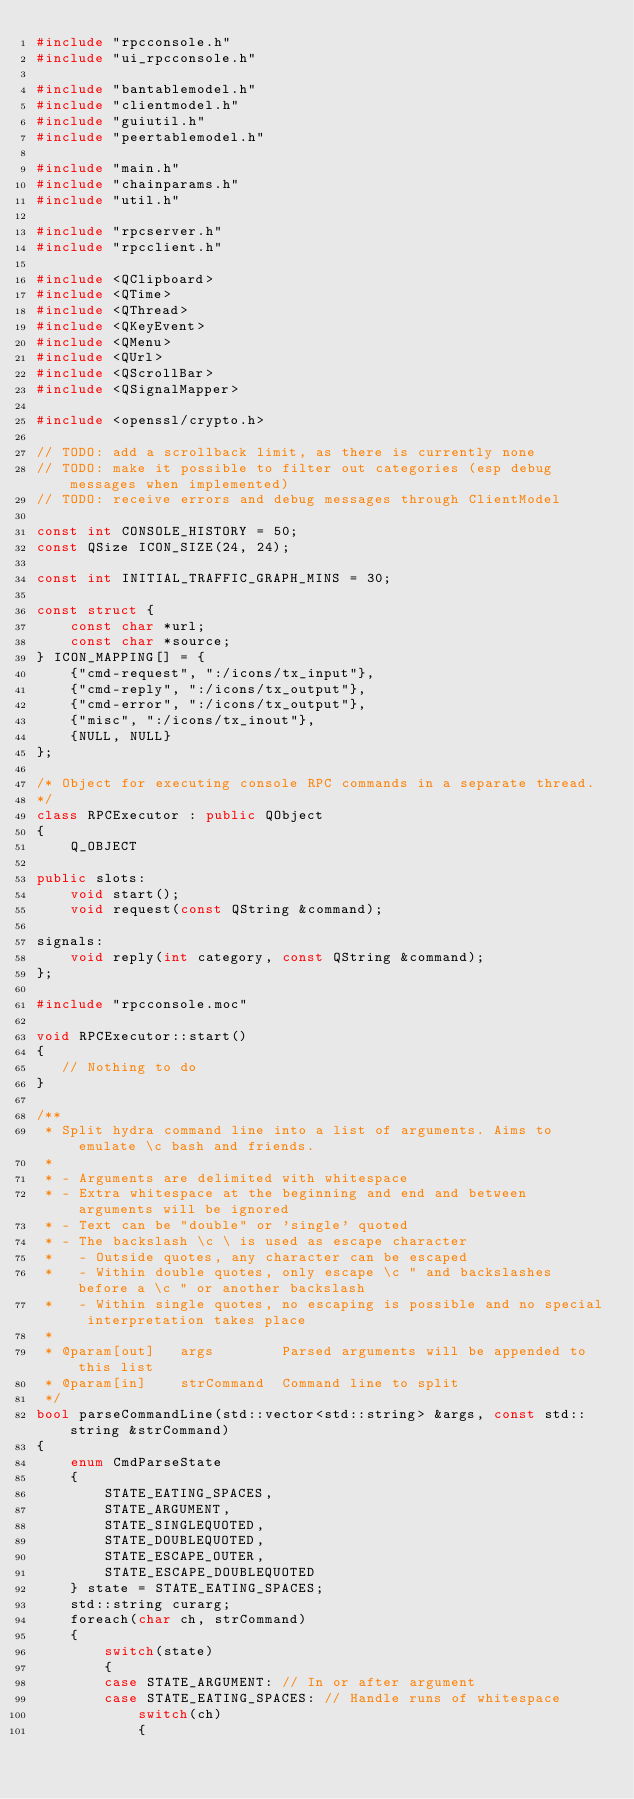Convert code to text. <code><loc_0><loc_0><loc_500><loc_500><_C++_>#include "rpcconsole.h"
#include "ui_rpcconsole.h"

#include "bantablemodel.h"
#include "clientmodel.h"
#include "guiutil.h"
#include "peertablemodel.h"

#include "main.h"
#include "chainparams.h"
#include "util.h"

#include "rpcserver.h"
#include "rpcclient.h"

#include <QClipboard>
#include <QTime>
#include <QThread>
#include <QKeyEvent>
#include <QMenu>
#include <QUrl>
#include <QScrollBar>
#include <QSignalMapper>

#include <openssl/crypto.h>

// TODO: add a scrollback limit, as there is currently none
// TODO: make it possible to filter out categories (esp debug messages when implemented)
// TODO: receive errors and debug messages through ClientModel

const int CONSOLE_HISTORY = 50;
const QSize ICON_SIZE(24, 24);

const int INITIAL_TRAFFIC_GRAPH_MINS = 30;

const struct {
    const char *url;
    const char *source;
} ICON_MAPPING[] = {
    {"cmd-request", ":/icons/tx_input"},
    {"cmd-reply", ":/icons/tx_output"},
    {"cmd-error", ":/icons/tx_output"},
    {"misc", ":/icons/tx_inout"},
    {NULL, NULL}
};

/* Object for executing console RPC commands in a separate thread.
*/
class RPCExecutor : public QObject
{
    Q_OBJECT

public slots:
    void start();
    void request(const QString &command);

signals:
    void reply(int category, const QString &command);
};

#include "rpcconsole.moc"

void RPCExecutor::start()
{
   // Nothing to do
}

/**
 * Split hydra command line into a list of arguments. Aims to emulate \c bash and friends.
 *
 * - Arguments are delimited with whitespace
 * - Extra whitespace at the beginning and end and between arguments will be ignored
 * - Text can be "double" or 'single' quoted
 * - The backslash \c \ is used as escape character
 *   - Outside quotes, any character can be escaped
 *   - Within double quotes, only escape \c " and backslashes before a \c " or another backslash
 *   - Within single quotes, no escaping is possible and no special interpretation takes place
 *
 * @param[out]   args        Parsed arguments will be appended to this list
 * @param[in]    strCommand  Command line to split
 */
bool parseCommandLine(std::vector<std::string> &args, const std::string &strCommand)
{
    enum CmdParseState
    {
        STATE_EATING_SPACES,
        STATE_ARGUMENT,
        STATE_SINGLEQUOTED,
        STATE_DOUBLEQUOTED,
        STATE_ESCAPE_OUTER,
        STATE_ESCAPE_DOUBLEQUOTED
    } state = STATE_EATING_SPACES;
    std::string curarg;
    foreach(char ch, strCommand)
    {
        switch(state)
        {
        case STATE_ARGUMENT: // In or after argument
        case STATE_EATING_SPACES: // Handle runs of whitespace
            switch(ch)
            {</code> 